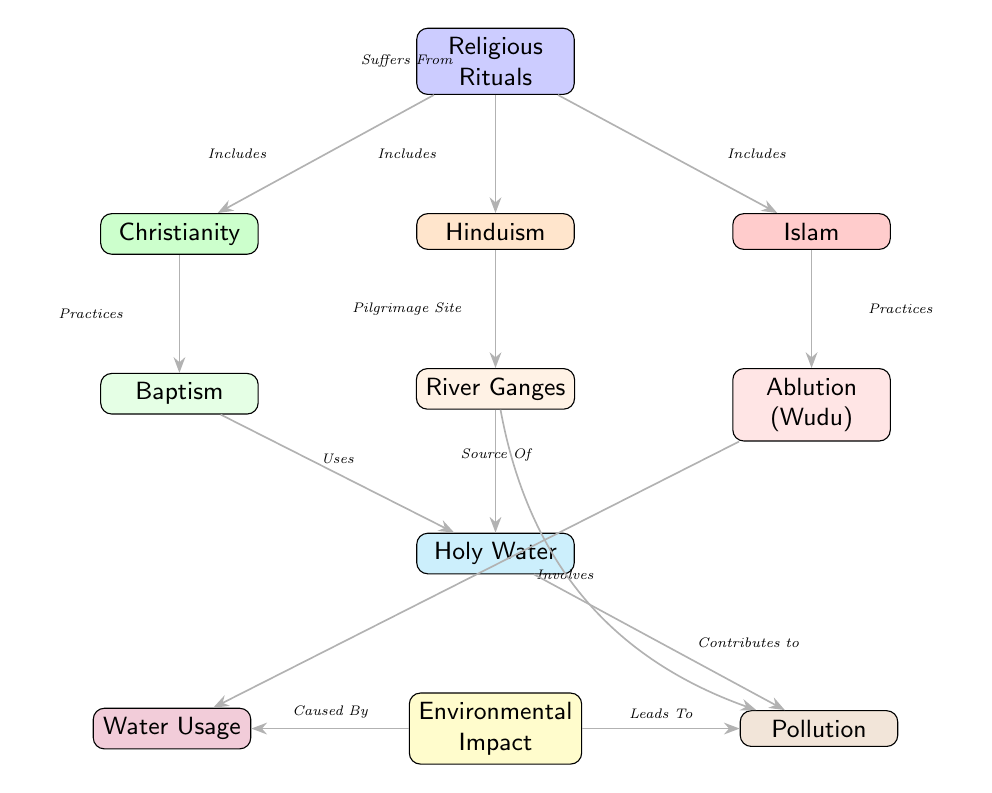What are the three religions included in religious rituals? The diagram identifies three religions connected to the node "Religious Rituals": Christianity, Hinduism, and Islam, which are represented as branches from the main node.
Answer: Christianity, Hinduism, Islam What specific religious practice is connected to Christianity? The diagram shows that the node "Baptism" is directly connected to "Christianity," indicated by the edge labeled "Practices." This demonstrates that Baptism is a specific religious practice within Christianity.
Answer: Baptism What type of water usage is linked with the node "Ablution (Wudu)"? The diagram presents the relationship between "Ablution (Wudu)" and the node "Water Usage," connected by the edge labeled "Involves." This implies that Ablution involves a certain amount of water use.
Answer: Water Usage How does "Holy Water" relate to the environmental impact? The edge labeled "Contributes to" links "Holy Water" with "Pollution," indicating that the use of Holy Water leads to environmental pollution. Additionally, there is a connection to "Environmental Impact," suggesting a broader implication.
Answer: Contributes to What does the "River Ganges" serve as in the context of Hinduism? In the diagram, "River Ganges" is denoted as a "Pilgrimage Site" connected directly to the node "Hinduism," illustrating its importance within the religious practice of Hinduism.
Answer: Pilgrimage Site What effect does "Environmental Impact" have on pollution? The edge labeled "Leads To" shows that "Environmental Impact" influences "Pollution," suggesting that the environmental outcomes of water usage in religious rituals can contribute to pollution.
Answer: Leads To Which religious practice is represented as a source of holy water? The diagram indicates that "River Ganges" has an edge labeled "Source Of" connecting it to "Holy Water," confirming that it serves as a source for holy water used in rituals.
Answer: Source Of What causes the environmental impact according to the diagram? The edge leading from "Environmental Impact" to "Water Usage" is labeled "Caused By," demonstrating that the water usage associated with religious rituals contributes to the environmental impact observed.
Answer: Caused By 